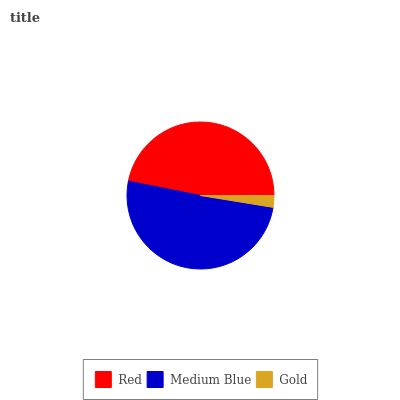Is Gold the minimum?
Answer yes or no. Yes. Is Medium Blue the maximum?
Answer yes or no. Yes. Is Medium Blue the minimum?
Answer yes or no. No. Is Gold the maximum?
Answer yes or no. No. Is Medium Blue greater than Gold?
Answer yes or no. Yes. Is Gold less than Medium Blue?
Answer yes or no. Yes. Is Gold greater than Medium Blue?
Answer yes or no. No. Is Medium Blue less than Gold?
Answer yes or no. No. Is Red the high median?
Answer yes or no. Yes. Is Red the low median?
Answer yes or no. Yes. Is Gold the high median?
Answer yes or no. No. Is Gold the low median?
Answer yes or no. No. 